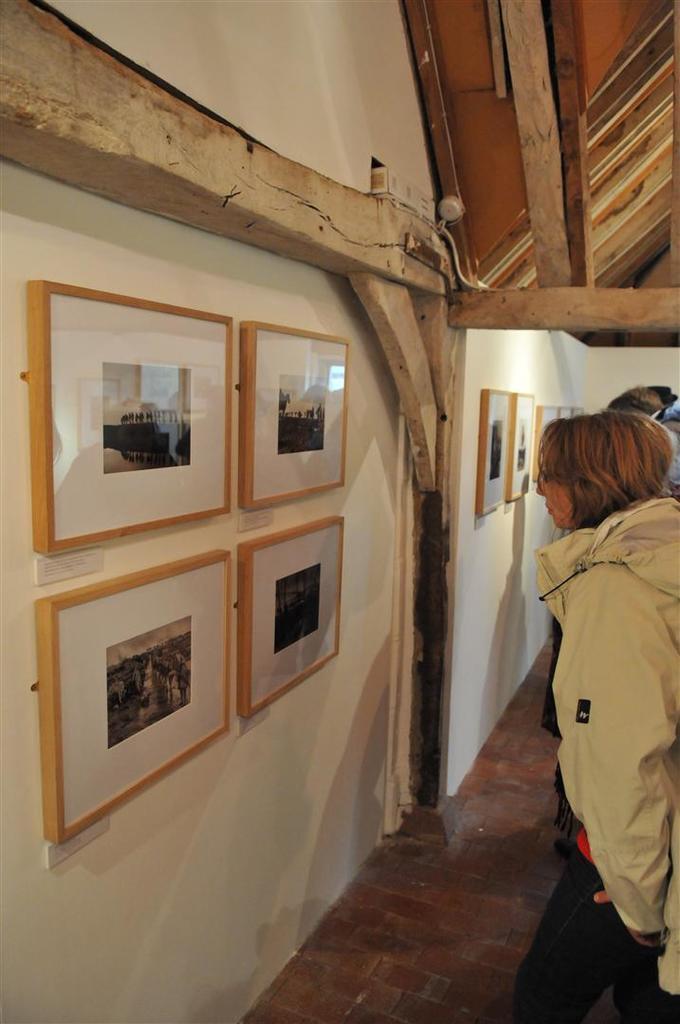Describe this image in one or two sentences. In this image I can see people standing on the right and there are photo frames on the walls, on the left. 